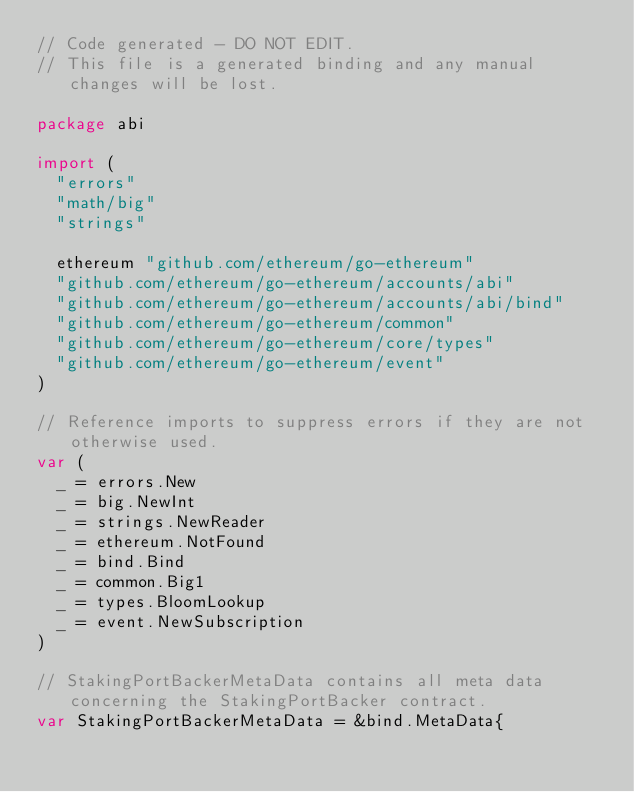Convert code to text. <code><loc_0><loc_0><loc_500><loc_500><_Go_>// Code generated - DO NOT EDIT.
// This file is a generated binding and any manual changes will be lost.

package abi

import (
	"errors"
	"math/big"
	"strings"

	ethereum "github.com/ethereum/go-ethereum"
	"github.com/ethereum/go-ethereum/accounts/abi"
	"github.com/ethereum/go-ethereum/accounts/abi/bind"
	"github.com/ethereum/go-ethereum/common"
	"github.com/ethereum/go-ethereum/core/types"
	"github.com/ethereum/go-ethereum/event"
)

// Reference imports to suppress errors if they are not otherwise used.
var (
	_ = errors.New
	_ = big.NewInt
	_ = strings.NewReader
	_ = ethereum.NotFound
	_ = bind.Bind
	_ = common.Big1
	_ = types.BloomLookup
	_ = event.NewSubscription
)

// StakingPortBackerMetaData contains all meta data concerning the StakingPortBacker contract.
var StakingPortBackerMetaData = &bind.MetaData{</code> 